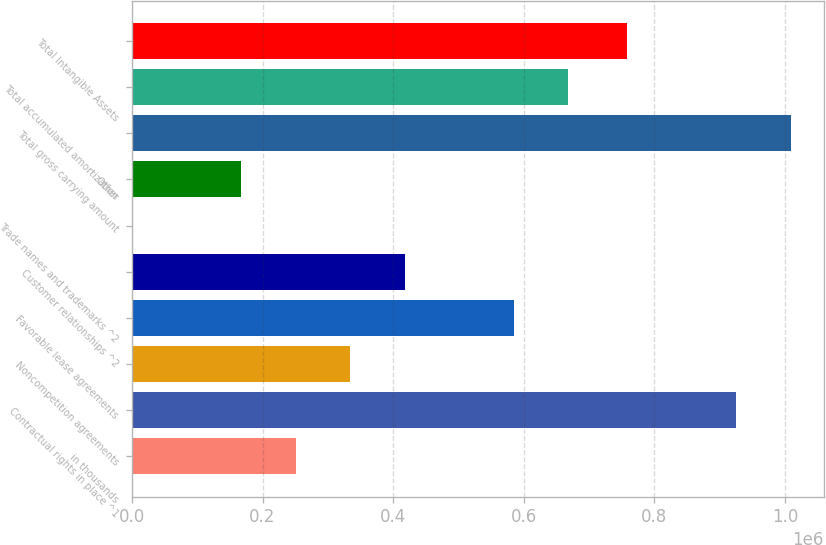Convert chart to OTSL. <chart><loc_0><loc_0><loc_500><loc_500><bar_chart><fcel>in thousands<fcel>Contractual rights in place ^1<fcel>Noncompetition agreements<fcel>Favorable lease agreements<fcel>Customer relationships ^2<fcel>Trade names and trademarks ^2<fcel>Other<fcel>Total gross carrying amount<fcel>Total accumulated amortization<fcel>Total Intangible Assets<nl><fcel>250700<fcel>925376<fcel>334267<fcel>584967<fcel>417834<fcel>0.16<fcel>167134<fcel>1.00894e+06<fcel>668534<fcel>758243<nl></chart> 